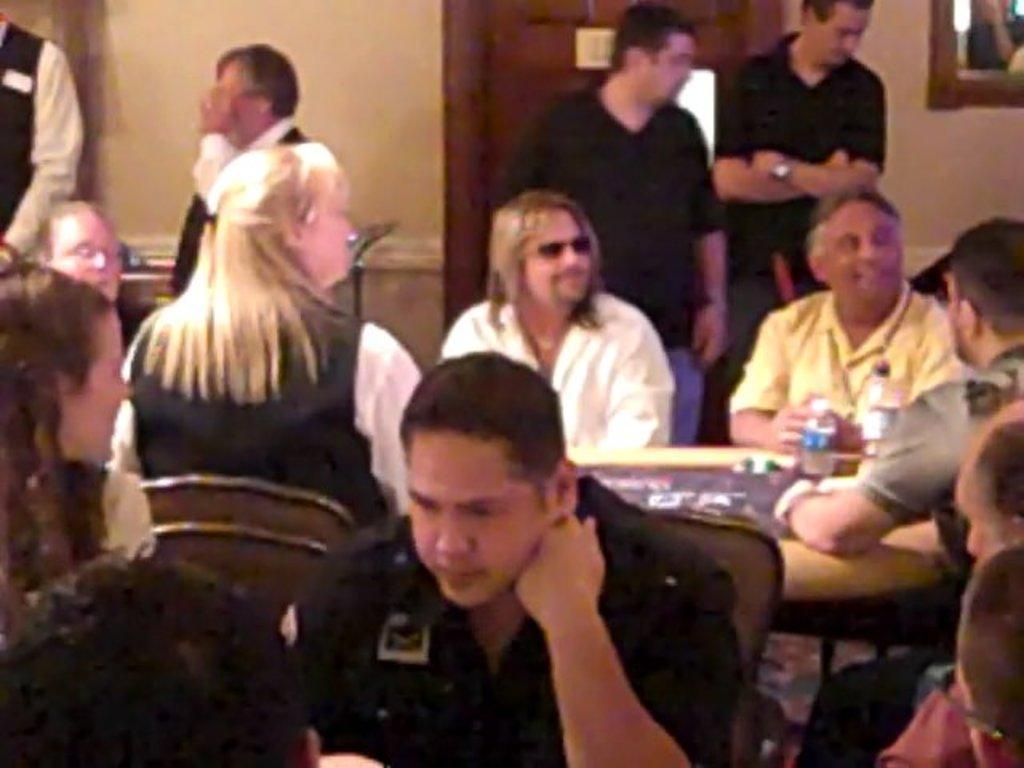Could you give a brief overview of what you see in this image? In the center of the image we can see a few people are sitting on the chairs and they are in different costumes. Among them, we can see a few people are smiling and few people are wearing glasses. And we can see chairs, one table, water bottle and a few other objects. In the background there is a wall, door, window, one table, few people are standing and a few other objects. 